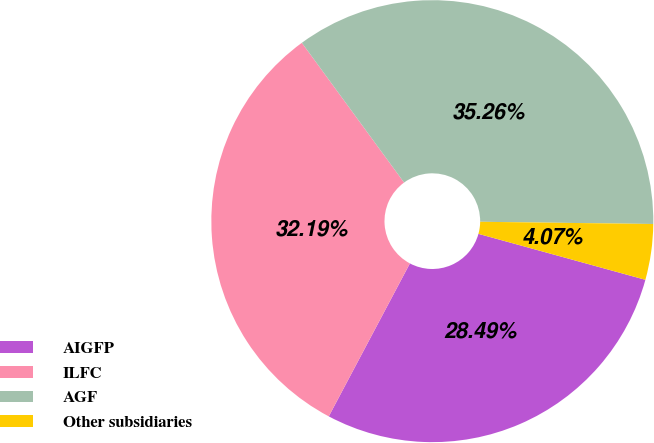Convert chart. <chart><loc_0><loc_0><loc_500><loc_500><pie_chart><fcel>AIGFP<fcel>ILFC<fcel>AGF<fcel>Other subsidiaries<nl><fcel>28.49%<fcel>32.19%<fcel>35.26%<fcel>4.07%<nl></chart> 